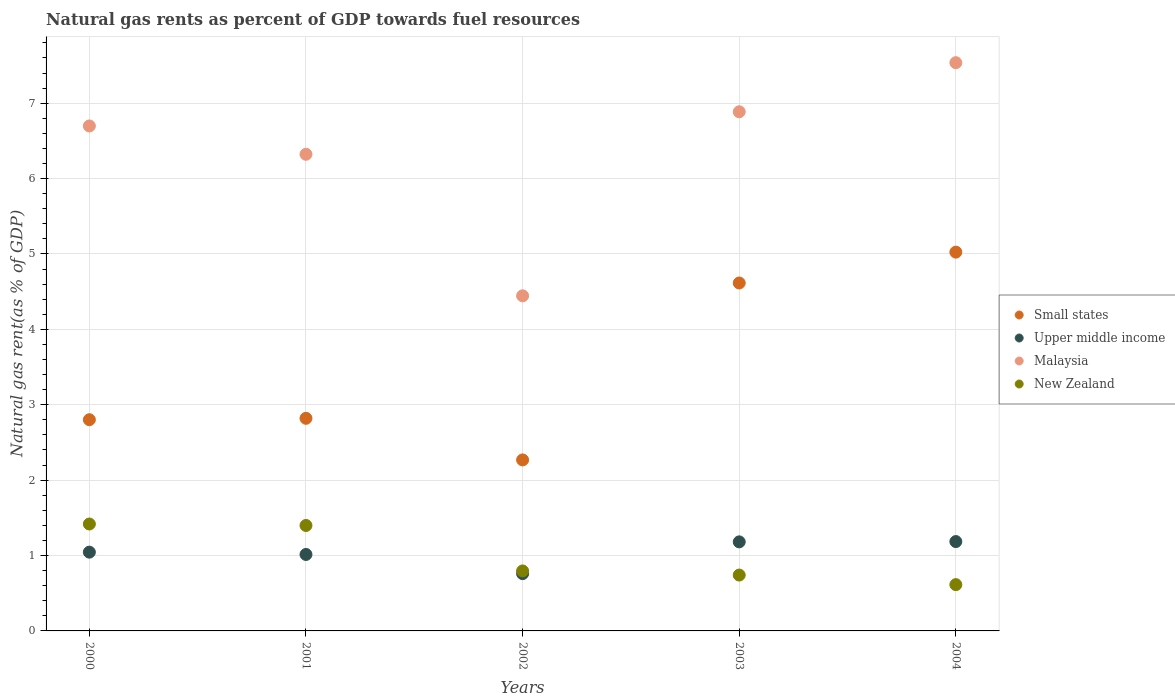Is the number of dotlines equal to the number of legend labels?
Offer a terse response. Yes. What is the natural gas rent in Malaysia in 2001?
Keep it short and to the point. 6.32. Across all years, what is the maximum natural gas rent in Upper middle income?
Your response must be concise. 1.19. Across all years, what is the minimum natural gas rent in Small states?
Your response must be concise. 2.27. In which year was the natural gas rent in Small states maximum?
Make the answer very short. 2004. What is the total natural gas rent in Small states in the graph?
Provide a short and direct response. 17.53. What is the difference between the natural gas rent in Small states in 2002 and that in 2003?
Your answer should be very brief. -2.35. What is the difference between the natural gas rent in Upper middle income in 2002 and the natural gas rent in Small states in 2001?
Provide a short and direct response. -2.06. What is the average natural gas rent in Upper middle income per year?
Provide a succinct answer. 1.04. In the year 2002, what is the difference between the natural gas rent in Malaysia and natural gas rent in New Zealand?
Your answer should be very brief. 3.65. In how many years, is the natural gas rent in Small states greater than 4.8 %?
Keep it short and to the point. 1. What is the ratio of the natural gas rent in New Zealand in 2002 to that in 2003?
Keep it short and to the point. 1.07. Is the natural gas rent in New Zealand in 2002 less than that in 2004?
Provide a succinct answer. No. Is the difference between the natural gas rent in Malaysia in 2000 and 2004 greater than the difference between the natural gas rent in New Zealand in 2000 and 2004?
Ensure brevity in your answer.  No. What is the difference between the highest and the second highest natural gas rent in New Zealand?
Offer a terse response. 0.02. What is the difference between the highest and the lowest natural gas rent in Upper middle income?
Give a very brief answer. 0.43. In how many years, is the natural gas rent in New Zealand greater than the average natural gas rent in New Zealand taken over all years?
Your response must be concise. 2. Is it the case that in every year, the sum of the natural gas rent in Malaysia and natural gas rent in Small states  is greater than the sum of natural gas rent in Upper middle income and natural gas rent in New Zealand?
Keep it short and to the point. Yes. Is the natural gas rent in New Zealand strictly greater than the natural gas rent in Small states over the years?
Your answer should be very brief. No. How many years are there in the graph?
Offer a terse response. 5. What is the title of the graph?
Provide a short and direct response. Natural gas rents as percent of GDP towards fuel resources. Does "Liberia" appear as one of the legend labels in the graph?
Give a very brief answer. No. What is the label or title of the Y-axis?
Give a very brief answer. Natural gas rent(as % of GDP). What is the Natural gas rent(as % of GDP) in Small states in 2000?
Your answer should be very brief. 2.8. What is the Natural gas rent(as % of GDP) of Upper middle income in 2000?
Your answer should be compact. 1.04. What is the Natural gas rent(as % of GDP) of Malaysia in 2000?
Give a very brief answer. 6.7. What is the Natural gas rent(as % of GDP) of New Zealand in 2000?
Offer a terse response. 1.42. What is the Natural gas rent(as % of GDP) of Small states in 2001?
Give a very brief answer. 2.82. What is the Natural gas rent(as % of GDP) of Upper middle income in 2001?
Offer a very short reply. 1.01. What is the Natural gas rent(as % of GDP) in Malaysia in 2001?
Offer a very short reply. 6.32. What is the Natural gas rent(as % of GDP) in New Zealand in 2001?
Your response must be concise. 1.4. What is the Natural gas rent(as % of GDP) of Small states in 2002?
Your answer should be very brief. 2.27. What is the Natural gas rent(as % of GDP) of Upper middle income in 2002?
Offer a terse response. 0.76. What is the Natural gas rent(as % of GDP) in Malaysia in 2002?
Your response must be concise. 4.45. What is the Natural gas rent(as % of GDP) of New Zealand in 2002?
Ensure brevity in your answer.  0.8. What is the Natural gas rent(as % of GDP) of Small states in 2003?
Your answer should be very brief. 4.62. What is the Natural gas rent(as % of GDP) of Upper middle income in 2003?
Offer a terse response. 1.18. What is the Natural gas rent(as % of GDP) in Malaysia in 2003?
Your answer should be compact. 6.89. What is the Natural gas rent(as % of GDP) in New Zealand in 2003?
Offer a very short reply. 0.74. What is the Natural gas rent(as % of GDP) of Small states in 2004?
Provide a succinct answer. 5.02. What is the Natural gas rent(as % of GDP) in Upper middle income in 2004?
Your response must be concise. 1.19. What is the Natural gas rent(as % of GDP) in Malaysia in 2004?
Make the answer very short. 7.54. What is the Natural gas rent(as % of GDP) of New Zealand in 2004?
Keep it short and to the point. 0.61. Across all years, what is the maximum Natural gas rent(as % of GDP) of Small states?
Give a very brief answer. 5.02. Across all years, what is the maximum Natural gas rent(as % of GDP) of Upper middle income?
Provide a succinct answer. 1.19. Across all years, what is the maximum Natural gas rent(as % of GDP) in Malaysia?
Your answer should be compact. 7.54. Across all years, what is the maximum Natural gas rent(as % of GDP) of New Zealand?
Make the answer very short. 1.42. Across all years, what is the minimum Natural gas rent(as % of GDP) of Small states?
Give a very brief answer. 2.27. Across all years, what is the minimum Natural gas rent(as % of GDP) of Upper middle income?
Keep it short and to the point. 0.76. Across all years, what is the minimum Natural gas rent(as % of GDP) of Malaysia?
Ensure brevity in your answer.  4.45. Across all years, what is the minimum Natural gas rent(as % of GDP) in New Zealand?
Provide a succinct answer. 0.61. What is the total Natural gas rent(as % of GDP) of Small states in the graph?
Your answer should be very brief. 17.53. What is the total Natural gas rent(as % of GDP) of Upper middle income in the graph?
Offer a terse response. 5.19. What is the total Natural gas rent(as % of GDP) of Malaysia in the graph?
Provide a short and direct response. 31.89. What is the total Natural gas rent(as % of GDP) in New Zealand in the graph?
Offer a terse response. 4.97. What is the difference between the Natural gas rent(as % of GDP) of Small states in 2000 and that in 2001?
Provide a succinct answer. -0.02. What is the difference between the Natural gas rent(as % of GDP) of Upper middle income in 2000 and that in 2001?
Your answer should be very brief. 0.03. What is the difference between the Natural gas rent(as % of GDP) of Malaysia in 2000 and that in 2001?
Your answer should be compact. 0.38. What is the difference between the Natural gas rent(as % of GDP) in New Zealand in 2000 and that in 2001?
Offer a very short reply. 0.02. What is the difference between the Natural gas rent(as % of GDP) in Small states in 2000 and that in 2002?
Give a very brief answer. 0.53. What is the difference between the Natural gas rent(as % of GDP) of Upper middle income in 2000 and that in 2002?
Your response must be concise. 0.28. What is the difference between the Natural gas rent(as % of GDP) in Malaysia in 2000 and that in 2002?
Offer a terse response. 2.25. What is the difference between the Natural gas rent(as % of GDP) of New Zealand in 2000 and that in 2002?
Your response must be concise. 0.62. What is the difference between the Natural gas rent(as % of GDP) in Small states in 2000 and that in 2003?
Give a very brief answer. -1.81. What is the difference between the Natural gas rent(as % of GDP) in Upper middle income in 2000 and that in 2003?
Your answer should be very brief. -0.14. What is the difference between the Natural gas rent(as % of GDP) in Malaysia in 2000 and that in 2003?
Keep it short and to the point. -0.19. What is the difference between the Natural gas rent(as % of GDP) of New Zealand in 2000 and that in 2003?
Your answer should be compact. 0.68. What is the difference between the Natural gas rent(as % of GDP) in Small states in 2000 and that in 2004?
Provide a succinct answer. -2.22. What is the difference between the Natural gas rent(as % of GDP) in Upper middle income in 2000 and that in 2004?
Your response must be concise. -0.14. What is the difference between the Natural gas rent(as % of GDP) in Malaysia in 2000 and that in 2004?
Your answer should be compact. -0.84. What is the difference between the Natural gas rent(as % of GDP) of New Zealand in 2000 and that in 2004?
Your answer should be very brief. 0.8. What is the difference between the Natural gas rent(as % of GDP) of Small states in 2001 and that in 2002?
Offer a very short reply. 0.55. What is the difference between the Natural gas rent(as % of GDP) in Upper middle income in 2001 and that in 2002?
Give a very brief answer. 0.25. What is the difference between the Natural gas rent(as % of GDP) of Malaysia in 2001 and that in 2002?
Your answer should be very brief. 1.88. What is the difference between the Natural gas rent(as % of GDP) of New Zealand in 2001 and that in 2002?
Give a very brief answer. 0.6. What is the difference between the Natural gas rent(as % of GDP) of Small states in 2001 and that in 2003?
Ensure brevity in your answer.  -1.8. What is the difference between the Natural gas rent(as % of GDP) in Upper middle income in 2001 and that in 2003?
Your response must be concise. -0.17. What is the difference between the Natural gas rent(as % of GDP) in Malaysia in 2001 and that in 2003?
Provide a short and direct response. -0.56. What is the difference between the Natural gas rent(as % of GDP) of New Zealand in 2001 and that in 2003?
Give a very brief answer. 0.66. What is the difference between the Natural gas rent(as % of GDP) of Small states in 2001 and that in 2004?
Your response must be concise. -2.2. What is the difference between the Natural gas rent(as % of GDP) of Upper middle income in 2001 and that in 2004?
Provide a short and direct response. -0.17. What is the difference between the Natural gas rent(as % of GDP) in Malaysia in 2001 and that in 2004?
Your response must be concise. -1.22. What is the difference between the Natural gas rent(as % of GDP) in New Zealand in 2001 and that in 2004?
Give a very brief answer. 0.78. What is the difference between the Natural gas rent(as % of GDP) of Small states in 2002 and that in 2003?
Your answer should be compact. -2.35. What is the difference between the Natural gas rent(as % of GDP) in Upper middle income in 2002 and that in 2003?
Ensure brevity in your answer.  -0.42. What is the difference between the Natural gas rent(as % of GDP) of Malaysia in 2002 and that in 2003?
Provide a short and direct response. -2.44. What is the difference between the Natural gas rent(as % of GDP) of New Zealand in 2002 and that in 2003?
Offer a very short reply. 0.05. What is the difference between the Natural gas rent(as % of GDP) in Small states in 2002 and that in 2004?
Give a very brief answer. -2.76. What is the difference between the Natural gas rent(as % of GDP) of Upper middle income in 2002 and that in 2004?
Give a very brief answer. -0.43. What is the difference between the Natural gas rent(as % of GDP) of Malaysia in 2002 and that in 2004?
Provide a succinct answer. -3.09. What is the difference between the Natural gas rent(as % of GDP) of New Zealand in 2002 and that in 2004?
Your answer should be very brief. 0.18. What is the difference between the Natural gas rent(as % of GDP) in Small states in 2003 and that in 2004?
Your answer should be compact. -0.41. What is the difference between the Natural gas rent(as % of GDP) of Upper middle income in 2003 and that in 2004?
Offer a very short reply. -0. What is the difference between the Natural gas rent(as % of GDP) in Malaysia in 2003 and that in 2004?
Give a very brief answer. -0.65. What is the difference between the Natural gas rent(as % of GDP) in New Zealand in 2003 and that in 2004?
Your response must be concise. 0.13. What is the difference between the Natural gas rent(as % of GDP) in Small states in 2000 and the Natural gas rent(as % of GDP) in Upper middle income in 2001?
Your answer should be compact. 1.79. What is the difference between the Natural gas rent(as % of GDP) of Small states in 2000 and the Natural gas rent(as % of GDP) of Malaysia in 2001?
Your response must be concise. -3.52. What is the difference between the Natural gas rent(as % of GDP) of Small states in 2000 and the Natural gas rent(as % of GDP) of New Zealand in 2001?
Keep it short and to the point. 1.4. What is the difference between the Natural gas rent(as % of GDP) in Upper middle income in 2000 and the Natural gas rent(as % of GDP) in Malaysia in 2001?
Your answer should be compact. -5.28. What is the difference between the Natural gas rent(as % of GDP) in Upper middle income in 2000 and the Natural gas rent(as % of GDP) in New Zealand in 2001?
Give a very brief answer. -0.35. What is the difference between the Natural gas rent(as % of GDP) of Malaysia in 2000 and the Natural gas rent(as % of GDP) of New Zealand in 2001?
Provide a short and direct response. 5.3. What is the difference between the Natural gas rent(as % of GDP) in Small states in 2000 and the Natural gas rent(as % of GDP) in Upper middle income in 2002?
Keep it short and to the point. 2.04. What is the difference between the Natural gas rent(as % of GDP) in Small states in 2000 and the Natural gas rent(as % of GDP) in Malaysia in 2002?
Offer a very short reply. -1.64. What is the difference between the Natural gas rent(as % of GDP) in Small states in 2000 and the Natural gas rent(as % of GDP) in New Zealand in 2002?
Make the answer very short. 2.01. What is the difference between the Natural gas rent(as % of GDP) in Upper middle income in 2000 and the Natural gas rent(as % of GDP) in Malaysia in 2002?
Give a very brief answer. -3.4. What is the difference between the Natural gas rent(as % of GDP) of Upper middle income in 2000 and the Natural gas rent(as % of GDP) of New Zealand in 2002?
Make the answer very short. 0.25. What is the difference between the Natural gas rent(as % of GDP) in Malaysia in 2000 and the Natural gas rent(as % of GDP) in New Zealand in 2002?
Offer a terse response. 5.9. What is the difference between the Natural gas rent(as % of GDP) of Small states in 2000 and the Natural gas rent(as % of GDP) of Upper middle income in 2003?
Offer a very short reply. 1.62. What is the difference between the Natural gas rent(as % of GDP) of Small states in 2000 and the Natural gas rent(as % of GDP) of Malaysia in 2003?
Ensure brevity in your answer.  -4.08. What is the difference between the Natural gas rent(as % of GDP) in Small states in 2000 and the Natural gas rent(as % of GDP) in New Zealand in 2003?
Offer a very short reply. 2.06. What is the difference between the Natural gas rent(as % of GDP) in Upper middle income in 2000 and the Natural gas rent(as % of GDP) in Malaysia in 2003?
Your response must be concise. -5.84. What is the difference between the Natural gas rent(as % of GDP) in Upper middle income in 2000 and the Natural gas rent(as % of GDP) in New Zealand in 2003?
Your answer should be compact. 0.3. What is the difference between the Natural gas rent(as % of GDP) of Malaysia in 2000 and the Natural gas rent(as % of GDP) of New Zealand in 2003?
Ensure brevity in your answer.  5.96. What is the difference between the Natural gas rent(as % of GDP) in Small states in 2000 and the Natural gas rent(as % of GDP) in Upper middle income in 2004?
Offer a very short reply. 1.62. What is the difference between the Natural gas rent(as % of GDP) of Small states in 2000 and the Natural gas rent(as % of GDP) of Malaysia in 2004?
Give a very brief answer. -4.74. What is the difference between the Natural gas rent(as % of GDP) of Small states in 2000 and the Natural gas rent(as % of GDP) of New Zealand in 2004?
Give a very brief answer. 2.19. What is the difference between the Natural gas rent(as % of GDP) of Upper middle income in 2000 and the Natural gas rent(as % of GDP) of Malaysia in 2004?
Give a very brief answer. -6.49. What is the difference between the Natural gas rent(as % of GDP) in Upper middle income in 2000 and the Natural gas rent(as % of GDP) in New Zealand in 2004?
Offer a terse response. 0.43. What is the difference between the Natural gas rent(as % of GDP) in Malaysia in 2000 and the Natural gas rent(as % of GDP) in New Zealand in 2004?
Provide a succinct answer. 6.08. What is the difference between the Natural gas rent(as % of GDP) of Small states in 2001 and the Natural gas rent(as % of GDP) of Upper middle income in 2002?
Your response must be concise. 2.06. What is the difference between the Natural gas rent(as % of GDP) in Small states in 2001 and the Natural gas rent(as % of GDP) in Malaysia in 2002?
Keep it short and to the point. -1.62. What is the difference between the Natural gas rent(as % of GDP) of Small states in 2001 and the Natural gas rent(as % of GDP) of New Zealand in 2002?
Give a very brief answer. 2.02. What is the difference between the Natural gas rent(as % of GDP) of Upper middle income in 2001 and the Natural gas rent(as % of GDP) of Malaysia in 2002?
Your response must be concise. -3.43. What is the difference between the Natural gas rent(as % of GDP) in Upper middle income in 2001 and the Natural gas rent(as % of GDP) in New Zealand in 2002?
Provide a succinct answer. 0.22. What is the difference between the Natural gas rent(as % of GDP) of Malaysia in 2001 and the Natural gas rent(as % of GDP) of New Zealand in 2002?
Your answer should be compact. 5.53. What is the difference between the Natural gas rent(as % of GDP) in Small states in 2001 and the Natural gas rent(as % of GDP) in Upper middle income in 2003?
Provide a short and direct response. 1.64. What is the difference between the Natural gas rent(as % of GDP) in Small states in 2001 and the Natural gas rent(as % of GDP) in Malaysia in 2003?
Provide a short and direct response. -4.07. What is the difference between the Natural gas rent(as % of GDP) of Small states in 2001 and the Natural gas rent(as % of GDP) of New Zealand in 2003?
Keep it short and to the point. 2.08. What is the difference between the Natural gas rent(as % of GDP) of Upper middle income in 2001 and the Natural gas rent(as % of GDP) of Malaysia in 2003?
Your answer should be very brief. -5.87. What is the difference between the Natural gas rent(as % of GDP) in Upper middle income in 2001 and the Natural gas rent(as % of GDP) in New Zealand in 2003?
Keep it short and to the point. 0.27. What is the difference between the Natural gas rent(as % of GDP) of Malaysia in 2001 and the Natural gas rent(as % of GDP) of New Zealand in 2003?
Offer a very short reply. 5.58. What is the difference between the Natural gas rent(as % of GDP) of Small states in 2001 and the Natural gas rent(as % of GDP) of Upper middle income in 2004?
Make the answer very short. 1.64. What is the difference between the Natural gas rent(as % of GDP) in Small states in 2001 and the Natural gas rent(as % of GDP) in Malaysia in 2004?
Your answer should be very brief. -4.72. What is the difference between the Natural gas rent(as % of GDP) in Small states in 2001 and the Natural gas rent(as % of GDP) in New Zealand in 2004?
Ensure brevity in your answer.  2.21. What is the difference between the Natural gas rent(as % of GDP) of Upper middle income in 2001 and the Natural gas rent(as % of GDP) of Malaysia in 2004?
Keep it short and to the point. -6.52. What is the difference between the Natural gas rent(as % of GDP) in Upper middle income in 2001 and the Natural gas rent(as % of GDP) in New Zealand in 2004?
Your answer should be very brief. 0.4. What is the difference between the Natural gas rent(as % of GDP) of Malaysia in 2001 and the Natural gas rent(as % of GDP) of New Zealand in 2004?
Ensure brevity in your answer.  5.71. What is the difference between the Natural gas rent(as % of GDP) in Small states in 2002 and the Natural gas rent(as % of GDP) in Upper middle income in 2003?
Give a very brief answer. 1.09. What is the difference between the Natural gas rent(as % of GDP) of Small states in 2002 and the Natural gas rent(as % of GDP) of Malaysia in 2003?
Keep it short and to the point. -4.62. What is the difference between the Natural gas rent(as % of GDP) of Small states in 2002 and the Natural gas rent(as % of GDP) of New Zealand in 2003?
Your answer should be compact. 1.53. What is the difference between the Natural gas rent(as % of GDP) in Upper middle income in 2002 and the Natural gas rent(as % of GDP) in Malaysia in 2003?
Your answer should be compact. -6.13. What is the difference between the Natural gas rent(as % of GDP) of Upper middle income in 2002 and the Natural gas rent(as % of GDP) of New Zealand in 2003?
Offer a terse response. 0.02. What is the difference between the Natural gas rent(as % of GDP) of Malaysia in 2002 and the Natural gas rent(as % of GDP) of New Zealand in 2003?
Provide a short and direct response. 3.7. What is the difference between the Natural gas rent(as % of GDP) of Small states in 2002 and the Natural gas rent(as % of GDP) of Upper middle income in 2004?
Offer a terse response. 1.08. What is the difference between the Natural gas rent(as % of GDP) of Small states in 2002 and the Natural gas rent(as % of GDP) of Malaysia in 2004?
Your answer should be very brief. -5.27. What is the difference between the Natural gas rent(as % of GDP) in Small states in 2002 and the Natural gas rent(as % of GDP) in New Zealand in 2004?
Your response must be concise. 1.65. What is the difference between the Natural gas rent(as % of GDP) in Upper middle income in 2002 and the Natural gas rent(as % of GDP) in Malaysia in 2004?
Your answer should be very brief. -6.78. What is the difference between the Natural gas rent(as % of GDP) of Upper middle income in 2002 and the Natural gas rent(as % of GDP) of New Zealand in 2004?
Your answer should be compact. 0.15. What is the difference between the Natural gas rent(as % of GDP) of Malaysia in 2002 and the Natural gas rent(as % of GDP) of New Zealand in 2004?
Provide a succinct answer. 3.83. What is the difference between the Natural gas rent(as % of GDP) of Small states in 2003 and the Natural gas rent(as % of GDP) of Upper middle income in 2004?
Make the answer very short. 3.43. What is the difference between the Natural gas rent(as % of GDP) of Small states in 2003 and the Natural gas rent(as % of GDP) of Malaysia in 2004?
Make the answer very short. -2.92. What is the difference between the Natural gas rent(as % of GDP) of Small states in 2003 and the Natural gas rent(as % of GDP) of New Zealand in 2004?
Provide a short and direct response. 4. What is the difference between the Natural gas rent(as % of GDP) of Upper middle income in 2003 and the Natural gas rent(as % of GDP) of Malaysia in 2004?
Ensure brevity in your answer.  -6.36. What is the difference between the Natural gas rent(as % of GDP) in Upper middle income in 2003 and the Natural gas rent(as % of GDP) in New Zealand in 2004?
Your answer should be compact. 0.57. What is the difference between the Natural gas rent(as % of GDP) of Malaysia in 2003 and the Natural gas rent(as % of GDP) of New Zealand in 2004?
Provide a succinct answer. 6.27. What is the average Natural gas rent(as % of GDP) of Small states per year?
Your response must be concise. 3.51. What is the average Natural gas rent(as % of GDP) of Upper middle income per year?
Your answer should be very brief. 1.04. What is the average Natural gas rent(as % of GDP) in Malaysia per year?
Ensure brevity in your answer.  6.38. In the year 2000, what is the difference between the Natural gas rent(as % of GDP) in Small states and Natural gas rent(as % of GDP) in Upper middle income?
Your response must be concise. 1.76. In the year 2000, what is the difference between the Natural gas rent(as % of GDP) in Small states and Natural gas rent(as % of GDP) in Malaysia?
Keep it short and to the point. -3.9. In the year 2000, what is the difference between the Natural gas rent(as % of GDP) of Small states and Natural gas rent(as % of GDP) of New Zealand?
Your answer should be compact. 1.38. In the year 2000, what is the difference between the Natural gas rent(as % of GDP) of Upper middle income and Natural gas rent(as % of GDP) of Malaysia?
Your answer should be compact. -5.65. In the year 2000, what is the difference between the Natural gas rent(as % of GDP) in Upper middle income and Natural gas rent(as % of GDP) in New Zealand?
Your response must be concise. -0.37. In the year 2000, what is the difference between the Natural gas rent(as % of GDP) in Malaysia and Natural gas rent(as % of GDP) in New Zealand?
Provide a succinct answer. 5.28. In the year 2001, what is the difference between the Natural gas rent(as % of GDP) in Small states and Natural gas rent(as % of GDP) in Upper middle income?
Give a very brief answer. 1.81. In the year 2001, what is the difference between the Natural gas rent(as % of GDP) in Small states and Natural gas rent(as % of GDP) in Malaysia?
Give a very brief answer. -3.5. In the year 2001, what is the difference between the Natural gas rent(as % of GDP) of Small states and Natural gas rent(as % of GDP) of New Zealand?
Your answer should be very brief. 1.42. In the year 2001, what is the difference between the Natural gas rent(as % of GDP) of Upper middle income and Natural gas rent(as % of GDP) of Malaysia?
Offer a terse response. -5.31. In the year 2001, what is the difference between the Natural gas rent(as % of GDP) in Upper middle income and Natural gas rent(as % of GDP) in New Zealand?
Your answer should be very brief. -0.38. In the year 2001, what is the difference between the Natural gas rent(as % of GDP) in Malaysia and Natural gas rent(as % of GDP) in New Zealand?
Give a very brief answer. 4.92. In the year 2002, what is the difference between the Natural gas rent(as % of GDP) of Small states and Natural gas rent(as % of GDP) of Upper middle income?
Your answer should be compact. 1.51. In the year 2002, what is the difference between the Natural gas rent(as % of GDP) of Small states and Natural gas rent(as % of GDP) of Malaysia?
Provide a succinct answer. -2.18. In the year 2002, what is the difference between the Natural gas rent(as % of GDP) in Small states and Natural gas rent(as % of GDP) in New Zealand?
Your answer should be compact. 1.47. In the year 2002, what is the difference between the Natural gas rent(as % of GDP) of Upper middle income and Natural gas rent(as % of GDP) of Malaysia?
Your answer should be very brief. -3.69. In the year 2002, what is the difference between the Natural gas rent(as % of GDP) of Upper middle income and Natural gas rent(as % of GDP) of New Zealand?
Give a very brief answer. -0.04. In the year 2002, what is the difference between the Natural gas rent(as % of GDP) of Malaysia and Natural gas rent(as % of GDP) of New Zealand?
Keep it short and to the point. 3.65. In the year 2003, what is the difference between the Natural gas rent(as % of GDP) of Small states and Natural gas rent(as % of GDP) of Upper middle income?
Offer a very short reply. 3.43. In the year 2003, what is the difference between the Natural gas rent(as % of GDP) in Small states and Natural gas rent(as % of GDP) in Malaysia?
Offer a terse response. -2.27. In the year 2003, what is the difference between the Natural gas rent(as % of GDP) in Small states and Natural gas rent(as % of GDP) in New Zealand?
Keep it short and to the point. 3.87. In the year 2003, what is the difference between the Natural gas rent(as % of GDP) of Upper middle income and Natural gas rent(as % of GDP) of Malaysia?
Offer a terse response. -5.71. In the year 2003, what is the difference between the Natural gas rent(as % of GDP) of Upper middle income and Natural gas rent(as % of GDP) of New Zealand?
Your response must be concise. 0.44. In the year 2003, what is the difference between the Natural gas rent(as % of GDP) in Malaysia and Natural gas rent(as % of GDP) in New Zealand?
Keep it short and to the point. 6.15. In the year 2004, what is the difference between the Natural gas rent(as % of GDP) of Small states and Natural gas rent(as % of GDP) of Upper middle income?
Provide a short and direct response. 3.84. In the year 2004, what is the difference between the Natural gas rent(as % of GDP) in Small states and Natural gas rent(as % of GDP) in Malaysia?
Your answer should be very brief. -2.51. In the year 2004, what is the difference between the Natural gas rent(as % of GDP) of Small states and Natural gas rent(as % of GDP) of New Zealand?
Make the answer very short. 4.41. In the year 2004, what is the difference between the Natural gas rent(as % of GDP) in Upper middle income and Natural gas rent(as % of GDP) in Malaysia?
Provide a short and direct response. -6.35. In the year 2004, what is the difference between the Natural gas rent(as % of GDP) in Upper middle income and Natural gas rent(as % of GDP) in New Zealand?
Keep it short and to the point. 0.57. In the year 2004, what is the difference between the Natural gas rent(as % of GDP) in Malaysia and Natural gas rent(as % of GDP) in New Zealand?
Your response must be concise. 6.92. What is the ratio of the Natural gas rent(as % of GDP) of Upper middle income in 2000 to that in 2001?
Make the answer very short. 1.03. What is the ratio of the Natural gas rent(as % of GDP) in Malaysia in 2000 to that in 2001?
Ensure brevity in your answer.  1.06. What is the ratio of the Natural gas rent(as % of GDP) of New Zealand in 2000 to that in 2001?
Make the answer very short. 1.01. What is the ratio of the Natural gas rent(as % of GDP) in Small states in 2000 to that in 2002?
Offer a terse response. 1.24. What is the ratio of the Natural gas rent(as % of GDP) in Upper middle income in 2000 to that in 2002?
Keep it short and to the point. 1.37. What is the ratio of the Natural gas rent(as % of GDP) in Malaysia in 2000 to that in 2002?
Your answer should be very brief. 1.51. What is the ratio of the Natural gas rent(as % of GDP) in New Zealand in 2000 to that in 2002?
Provide a succinct answer. 1.78. What is the ratio of the Natural gas rent(as % of GDP) in Small states in 2000 to that in 2003?
Give a very brief answer. 0.61. What is the ratio of the Natural gas rent(as % of GDP) in Upper middle income in 2000 to that in 2003?
Ensure brevity in your answer.  0.88. What is the ratio of the Natural gas rent(as % of GDP) in Malaysia in 2000 to that in 2003?
Your answer should be very brief. 0.97. What is the ratio of the Natural gas rent(as % of GDP) of New Zealand in 2000 to that in 2003?
Your answer should be very brief. 1.91. What is the ratio of the Natural gas rent(as % of GDP) of Small states in 2000 to that in 2004?
Your answer should be compact. 0.56. What is the ratio of the Natural gas rent(as % of GDP) of Upper middle income in 2000 to that in 2004?
Offer a terse response. 0.88. What is the ratio of the Natural gas rent(as % of GDP) of Malaysia in 2000 to that in 2004?
Provide a short and direct response. 0.89. What is the ratio of the Natural gas rent(as % of GDP) in New Zealand in 2000 to that in 2004?
Offer a terse response. 2.31. What is the ratio of the Natural gas rent(as % of GDP) in Small states in 2001 to that in 2002?
Make the answer very short. 1.24. What is the ratio of the Natural gas rent(as % of GDP) in Upper middle income in 2001 to that in 2002?
Offer a very short reply. 1.33. What is the ratio of the Natural gas rent(as % of GDP) of Malaysia in 2001 to that in 2002?
Ensure brevity in your answer.  1.42. What is the ratio of the Natural gas rent(as % of GDP) of New Zealand in 2001 to that in 2002?
Your answer should be very brief. 1.76. What is the ratio of the Natural gas rent(as % of GDP) of Small states in 2001 to that in 2003?
Your response must be concise. 0.61. What is the ratio of the Natural gas rent(as % of GDP) in Upper middle income in 2001 to that in 2003?
Your answer should be very brief. 0.86. What is the ratio of the Natural gas rent(as % of GDP) in Malaysia in 2001 to that in 2003?
Provide a short and direct response. 0.92. What is the ratio of the Natural gas rent(as % of GDP) of New Zealand in 2001 to that in 2003?
Your answer should be compact. 1.89. What is the ratio of the Natural gas rent(as % of GDP) in Small states in 2001 to that in 2004?
Offer a very short reply. 0.56. What is the ratio of the Natural gas rent(as % of GDP) in Upper middle income in 2001 to that in 2004?
Your response must be concise. 0.86. What is the ratio of the Natural gas rent(as % of GDP) of Malaysia in 2001 to that in 2004?
Keep it short and to the point. 0.84. What is the ratio of the Natural gas rent(as % of GDP) of New Zealand in 2001 to that in 2004?
Provide a succinct answer. 2.28. What is the ratio of the Natural gas rent(as % of GDP) in Small states in 2002 to that in 2003?
Ensure brevity in your answer.  0.49. What is the ratio of the Natural gas rent(as % of GDP) of Upper middle income in 2002 to that in 2003?
Offer a terse response. 0.64. What is the ratio of the Natural gas rent(as % of GDP) of Malaysia in 2002 to that in 2003?
Keep it short and to the point. 0.65. What is the ratio of the Natural gas rent(as % of GDP) of New Zealand in 2002 to that in 2003?
Provide a short and direct response. 1.07. What is the ratio of the Natural gas rent(as % of GDP) of Small states in 2002 to that in 2004?
Give a very brief answer. 0.45. What is the ratio of the Natural gas rent(as % of GDP) in Upper middle income in 2002 to that in 2004?
Offer a very short reply. 0.64. What is the ratio of the Natural gas rent(as % of GDP) in Malaysia in 2002 to that in 2004?
Provide a succinct answer. 0.59. What is the ratio of the Natural gas rent(as % of GDP) in New Zealand in 2002 to that in 2004?
Your answer should be compact. 1.3. What is the ratio of the Natural gas rent(as % of GDP) of Small states in 2003 to that in 2004?
Your answer should be very brief. 0.92. What is the ratio of the Natural gas rent(as % of GDP) in Malaysia in 2003 to that in 2004?
Provide a succinct answer. 0.91. What is the ratio of the Natural gas rent(as % of GDP) in New Zealand in 2003 to that in 2004?
Make the answer very short. 1.21. What is the difference between the highest and the second highest Natural gas rent(as % of GDP) in Small states?
Give a very brief answer. 0.41. What is the difference between the highest and the second highest Natural gas rent(as % of GDP) of Upper middle income?
Give a very brief answer. 0. What is the difference between the highest and the second highest Natural gas rent(as % of GDP) in Malaysia?
Provide a succinct answer. 0.65. What is the difference between the highest and the second highest Natural gas rent(as % of GDP) in New Zealand?
Your answer should be compact. 0.02. What is the difference between the highest and the lowest Natural gas rent(as % of GDP) of Small states?
Offer a very short reply. 2.76. What is the difference between the highest and the lowest Natural gas rent(as % of GDP) of Upper middle income?
Make the answer very short. 0.43. What is the difference between the highest and the lowest Natural gas rent(as % of GDP) of Malaysia?
Provide a short and direct response. 3.09. What is the difference between the highest and the lowest Natural gas rent(as % of GDP) in New Zealand?
Your answer should be compact. 0.8. 